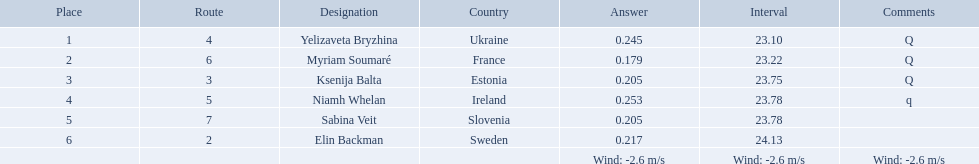Which athlete is from sweden? Elin Backman. What was their time to finish the race? 24.13. What place did elin backman finish the race in? 6. How long did it take him to finish? 24.13. 